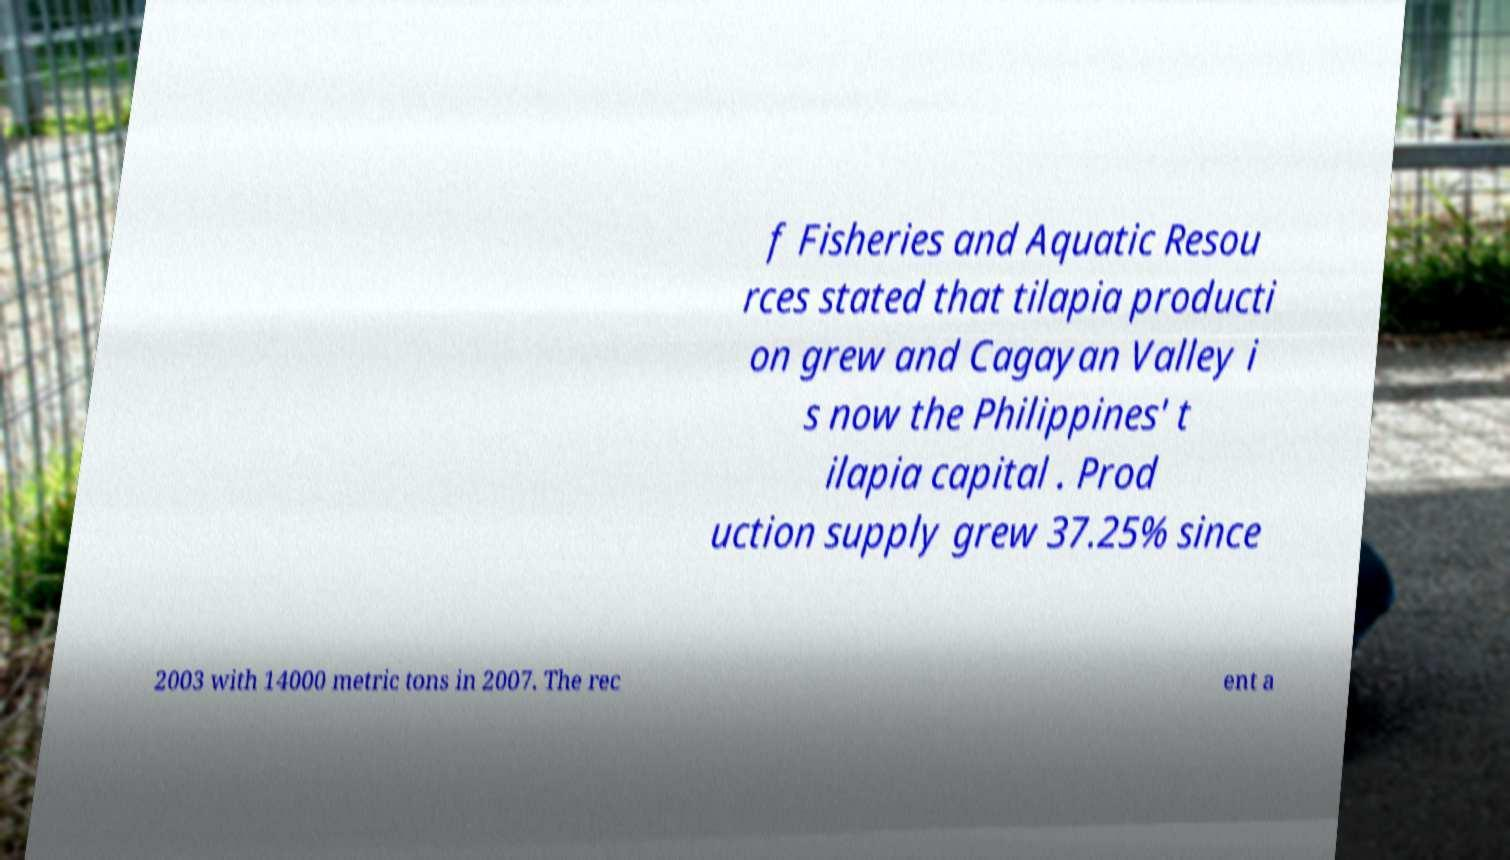For documentation purposes, I need the text within this image transcribed. Could you provide that? f Fisheries and Aquatic Resou rces stated that tilapia producti on grew and Cagayan Valley i s now the Philippines' t ilapia capital . Prod uction supply grew 37.25% since 2003 with 14000 metric tons in 2007. The rec ent a 